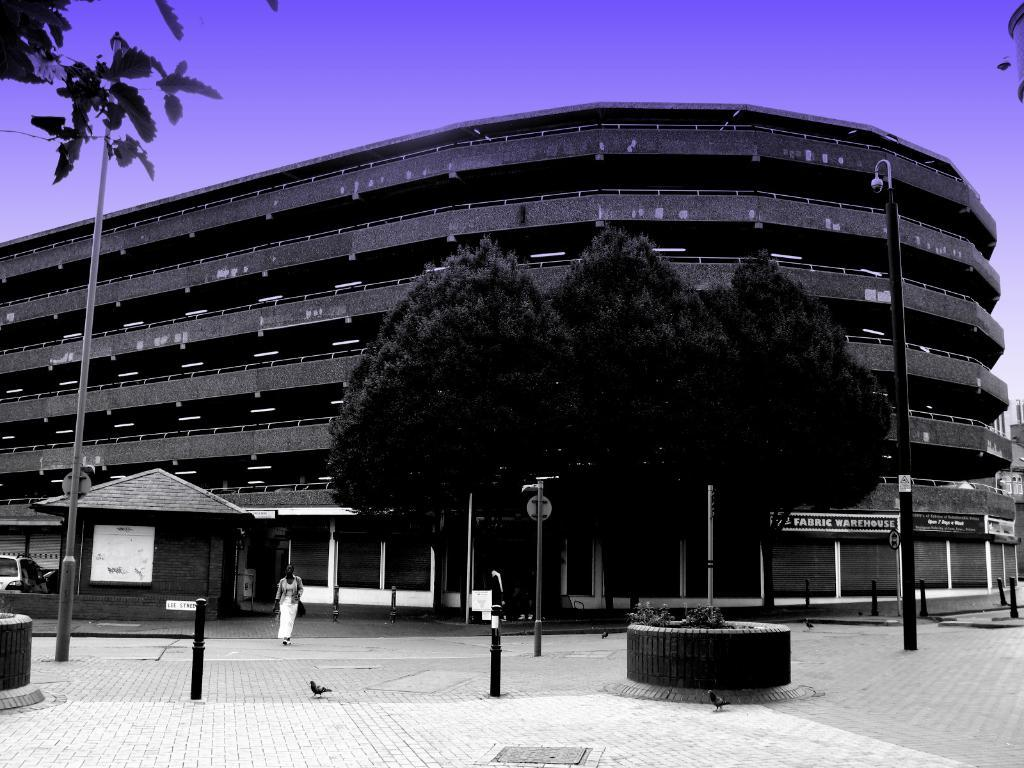What type of structures can be seen in the image? There are buildings in the image. What else can be seen in the image besides buildings? There are poles, birds, trees, lights, boards, plants, vehicles, and the sky visible in the background of the image. What type of pain is the person experiencing in the image? There is no person present in the image, and therefore no indication of any pain being experienced. 